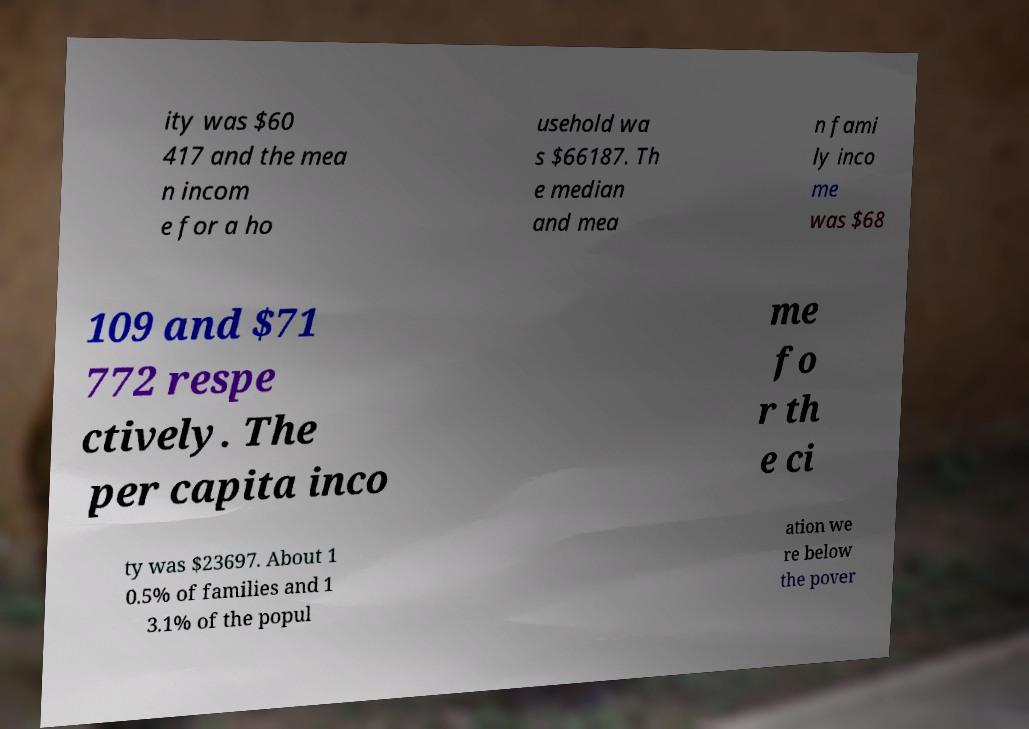Please read and relay the text visible in this image. What does it say? ity was $60 417 and the mea n incom e for a ho usehold wa s $66187. Th e median and mea n fami ly inco me was $68 109 and $71 772 respe ctively. The per capita inco me fo r th e ci ty was $23697. About 1 0.5% of families and 1 3.1% of the popul ation we re below the pover 